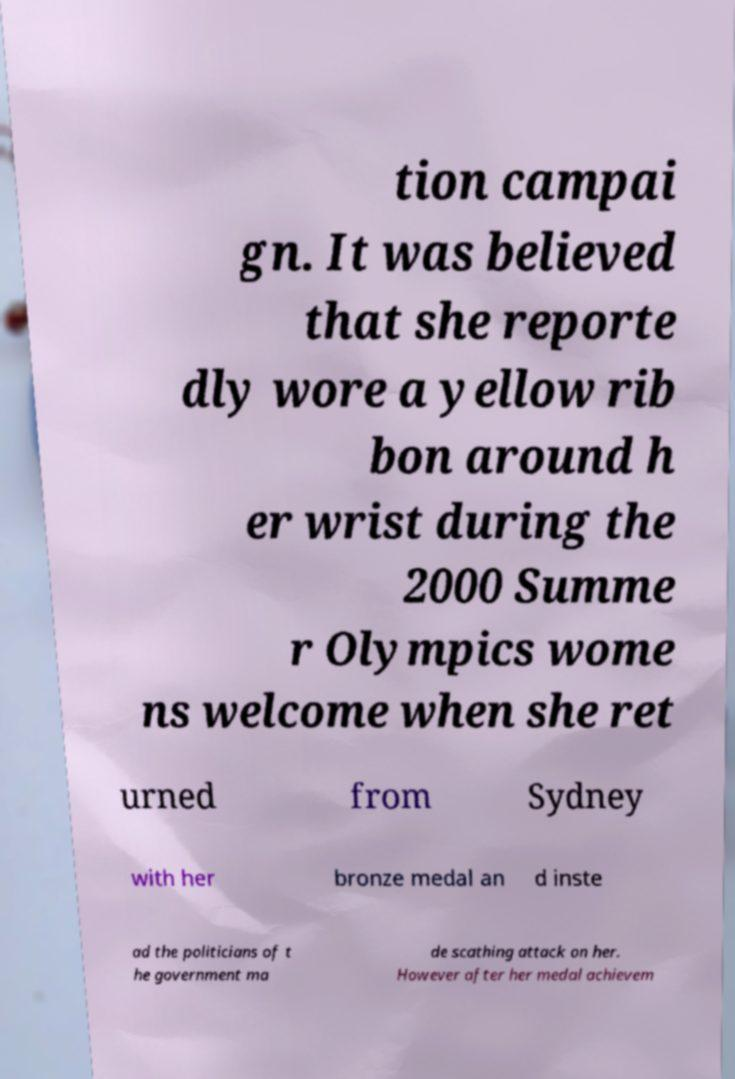Please identify and transcribe the text found in this image. tion campai gn. It was believed that she reporte dly wore a yellow rib bon around h er wrist during the 2000 Summe r Olympics wome ns welcome when she ret urned from Sydney with her bronze medal an d inste ad the politicians of t he government ma de scathing attack on her. However after her medal achievem 